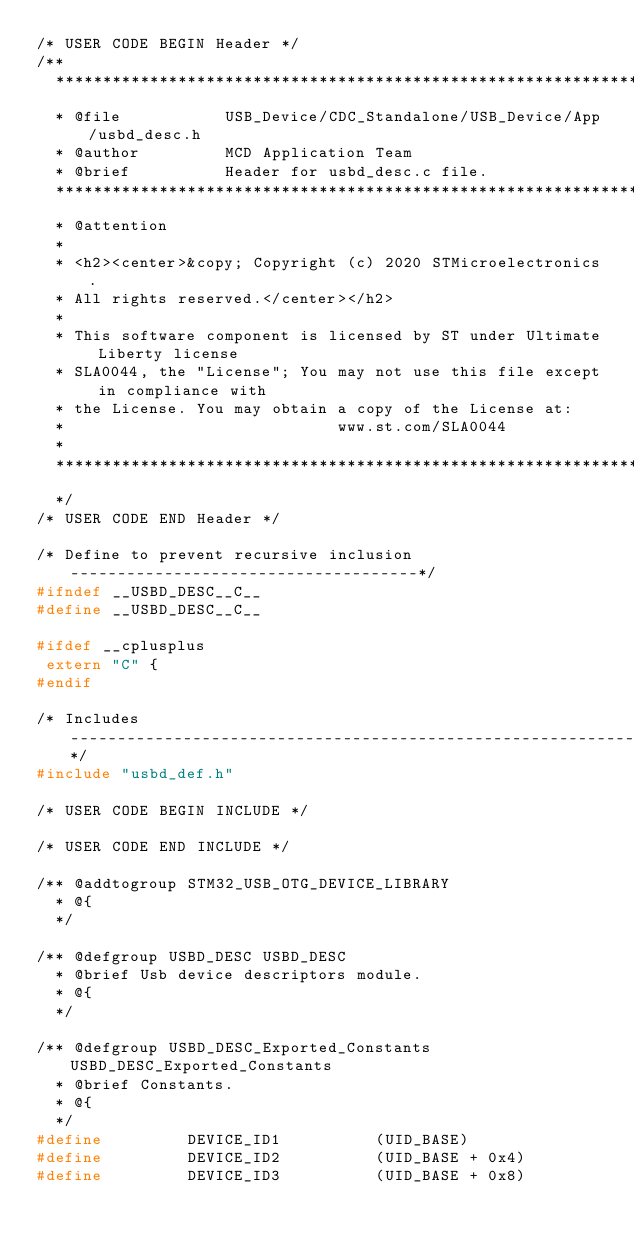Convert code to text. <code><loc_0><loc_0><loc_500><loc_500><_C_>/* USER CODE BEGIN Header */
/**
  ******************************************************************************
  * @file           USB_Device/CDC_Standalone/USB_Device/App/usbd_desc.h
  * @author         MCD Application Team
  * @brief          Header for usbd_desc.c file.
  ******************************************************************************
  * @attention
  *
  * <h2><center>&copy; Copyright (c) 2020 STMicroelectronics.
  * All rights reserved.</center></h2>
  *
  * This software component is licensed by ST under Ultimate Liberty license
  * SLA0044, the "License"; You may not use this file except in compliance with
  * the License. You may obtain a copy of the License at:
  *                             www.st.com/SLA0044
  *
  ******************************************************************************
  */
/* USER CODE END Header */

/* Define to prevent recursive inclusion -------------------------------------*/
#ifndef __USBD_DESC__C__
#define __USBD_DESC__C__

#ifdef __cplusplus
 extern "C" {
#endif

/* Includes ------------------------------------------------------------------*/
#include "usbd_def.h"

/* USER CODE BEGIN INCLUDE */

/* USER CODE END INCLUDE */

/** @addtogroup STM32_USB_OTG_DEVICE_LIBRARY
  * @{
  */

/** @defgroup USBD_DESC USBD_DESC
  * @brief Usb device descriptors module.
  * @{
  */

/** @defgroup USBD_DESC_Exported_Constants USBD_DESC_Exported_Constants
  * @brief Constants.
  * @{
  */
#define         DEVICE_ID1          (UID_BASE)
#define         DEVICE_ID2          (UID_BASE + 0x4)
#define         DEVICE_ID3          (UID_BASE + 0x8)
</code> 